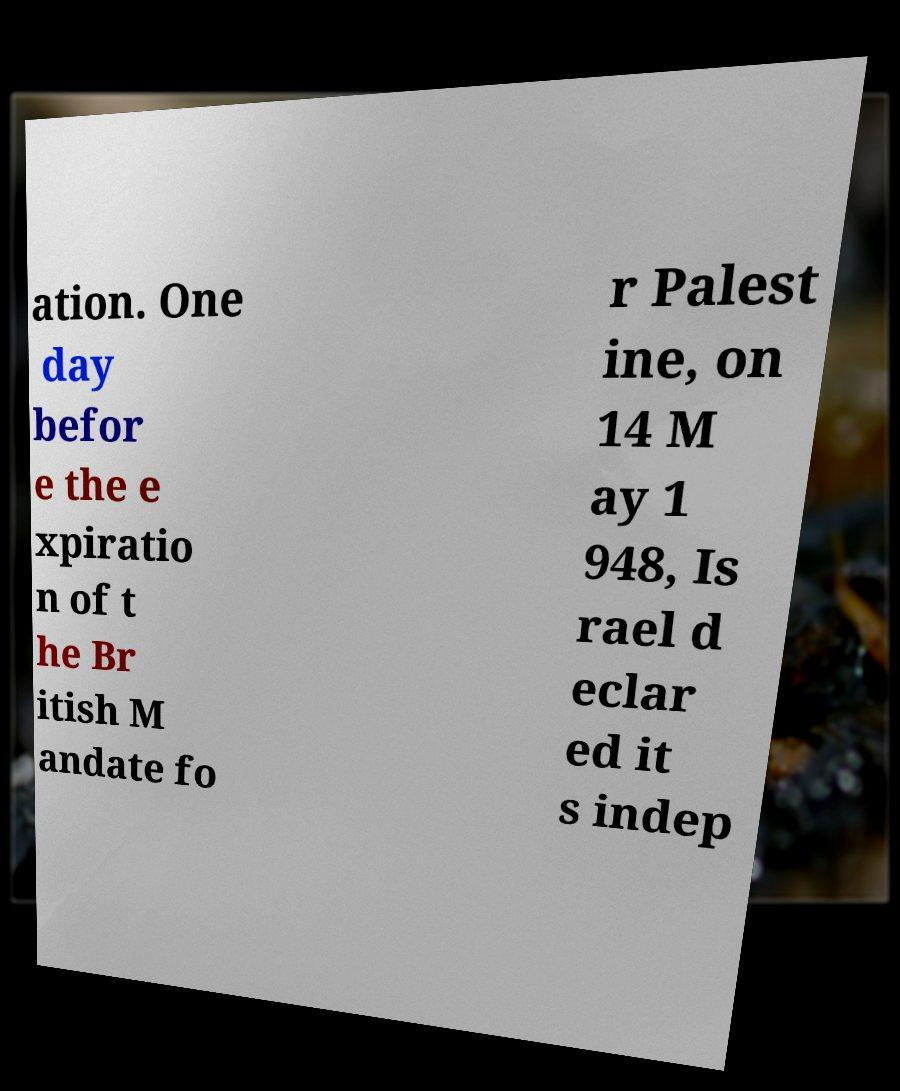Can you accurately transcribe the text from the provided image for me? ation. One day befor e the e xpiratio n of t he Br itish M andate fo r Palest ine, on 14 M ay 1 948, Is rael d eclar ed it s indep 